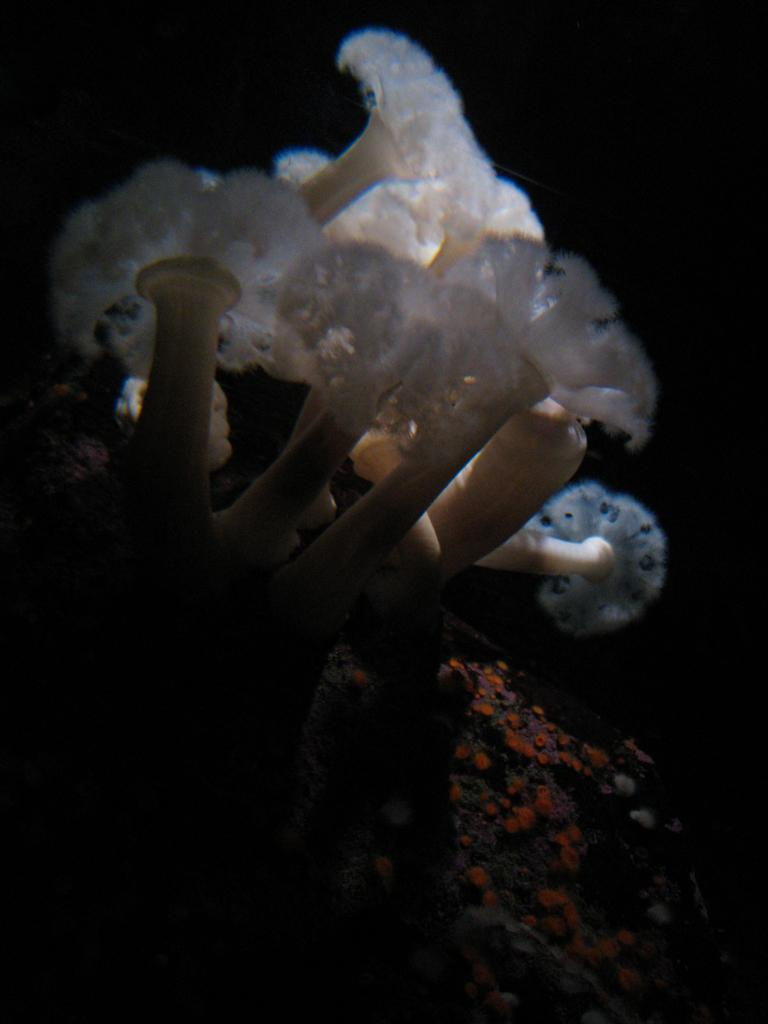What is the main subject of the image? The main subject of the image is a water plant. Where is the water plant located? The water plant is in the center of the image. What is the water plant situated in? The water plant is in water. What can be seen at the bottom of the image? Soil is present at the bottom of the image. How does the water plant react to the quilt in the image? There is no quilt present in the image, so the water plant cannot react to it. 